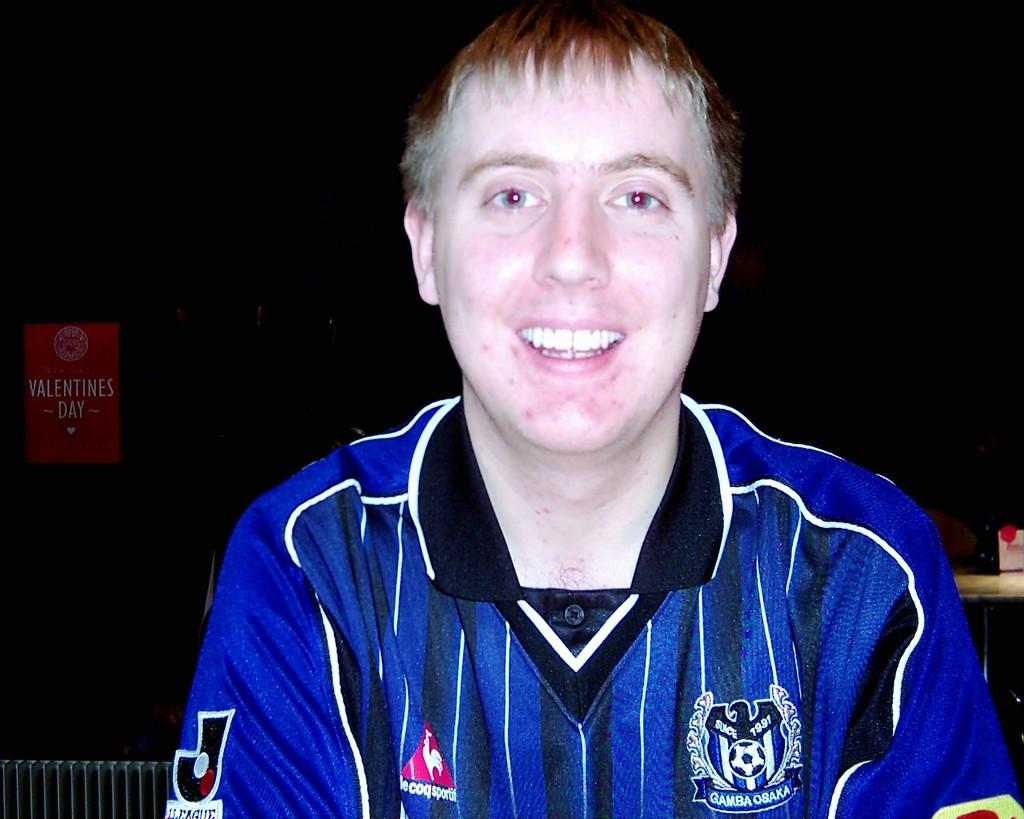<image>
Write a terse but informative summary of the picture. A man wearing a blue shirt which has the date 1991 on it. 